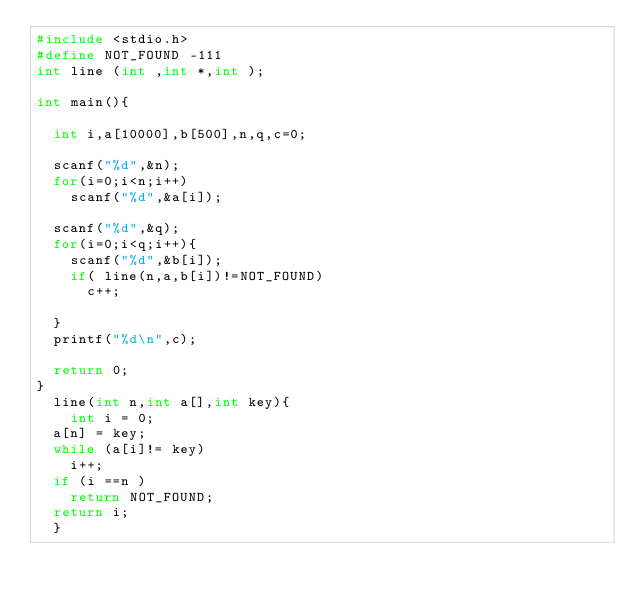Convert code to text. <code><loc_0><loc_0><loc_500><loc_500><_C_>#include <stdio.h>
#define NOT_FOUND -111
int line (int ,int *,int );

int main(){
  
  int i,a[10000],b[500],n,q,c=0;
  
  scanf("%d",&n);
  for(i=0;i<n;i++)
    scanf("%d",&a[i]);
  
  scanf("%d",&q);
  for(i=0;i<q;i++){
    scanf("%d",&b[i]);
    if( line(n,a,b[i])!=NOT_FOUND)
      c++;
      
  }
  printf("%d\n",c);

  return 0;
} 
  line(int n,int a[],int key){
    int i = 0;
  a[n] = key;
  while (a[i]!= key) 
    i++;
  if (i ==n )
    return NOT_FOUND;
  return i;
  }

</code> 